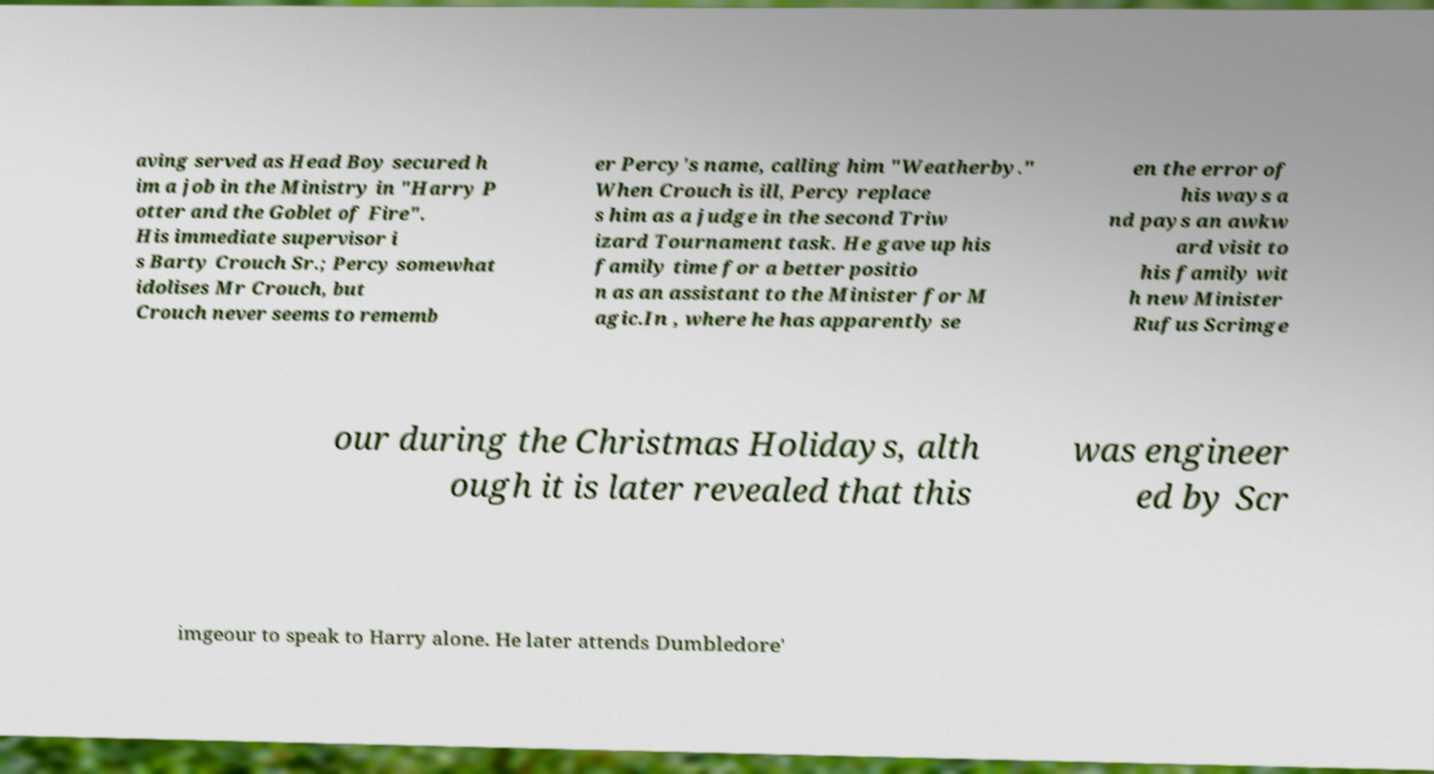What messages or text are displayed in this image? I need them in a readable, typed format. aving served as Head Boy secured h im a job in the Ministry in "Harry P otter and the Goblet of Fire". His immediate supervisor i s Barty Crouch Sr.; Percy somewhat idolises Mr Crouch, but Crouch never seems to rememb er Percy's name, calling him "Weatherby." When Crouch is ill, Percy replace s him as a judge in the second Triw izard Tournament task. He gave up his family time for a better positio n as an assistant to the Minister for M agic.In , where he has apparently se en the error of his ways a nd pays an awkw ard visit to his family wit h new Minister Rufus Scrimge our during the Christmas Holidays, alth ough it is later revealed that this was engineer ed by Scr imgeour to speak to Harry alone. He later attends Dumbledore' 